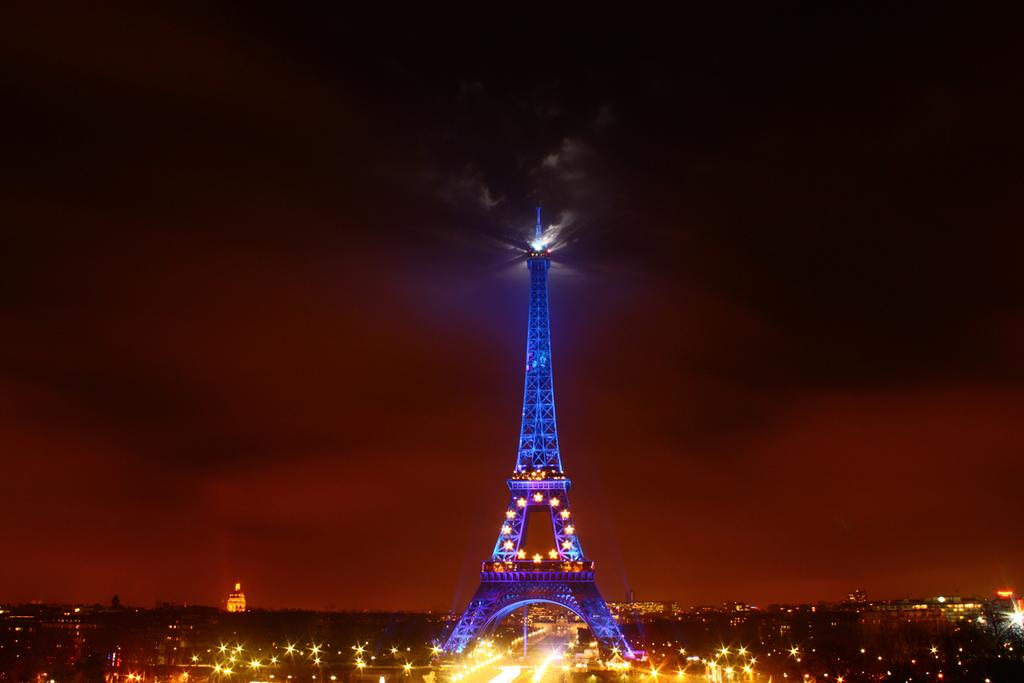What famous landmark is present in the image? The Eiffel Tower is present in the image. What can be seen illuminated in the image? There are lights visible in the image. How would you describe the overall lighting in the image? The image appears to be slightly dark. How many sheep are present in the image? There are no sheep present in the image. What type of body is visible in the image? There is no body present in the image; it features the Eiffel Tower and lights. 